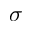<formula> <loc_0><loc_0><loc_500><loc_500>\sigma</formula> 